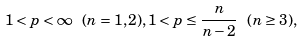<formula> <loc_0><loc_0><loc_500><loc_500>1 < p < \infty \ ( n = 1 , 2 ) , 1 < p \leq \frac { n } { n - 2 } \ ( n \geq 3 ) ,</formula> 